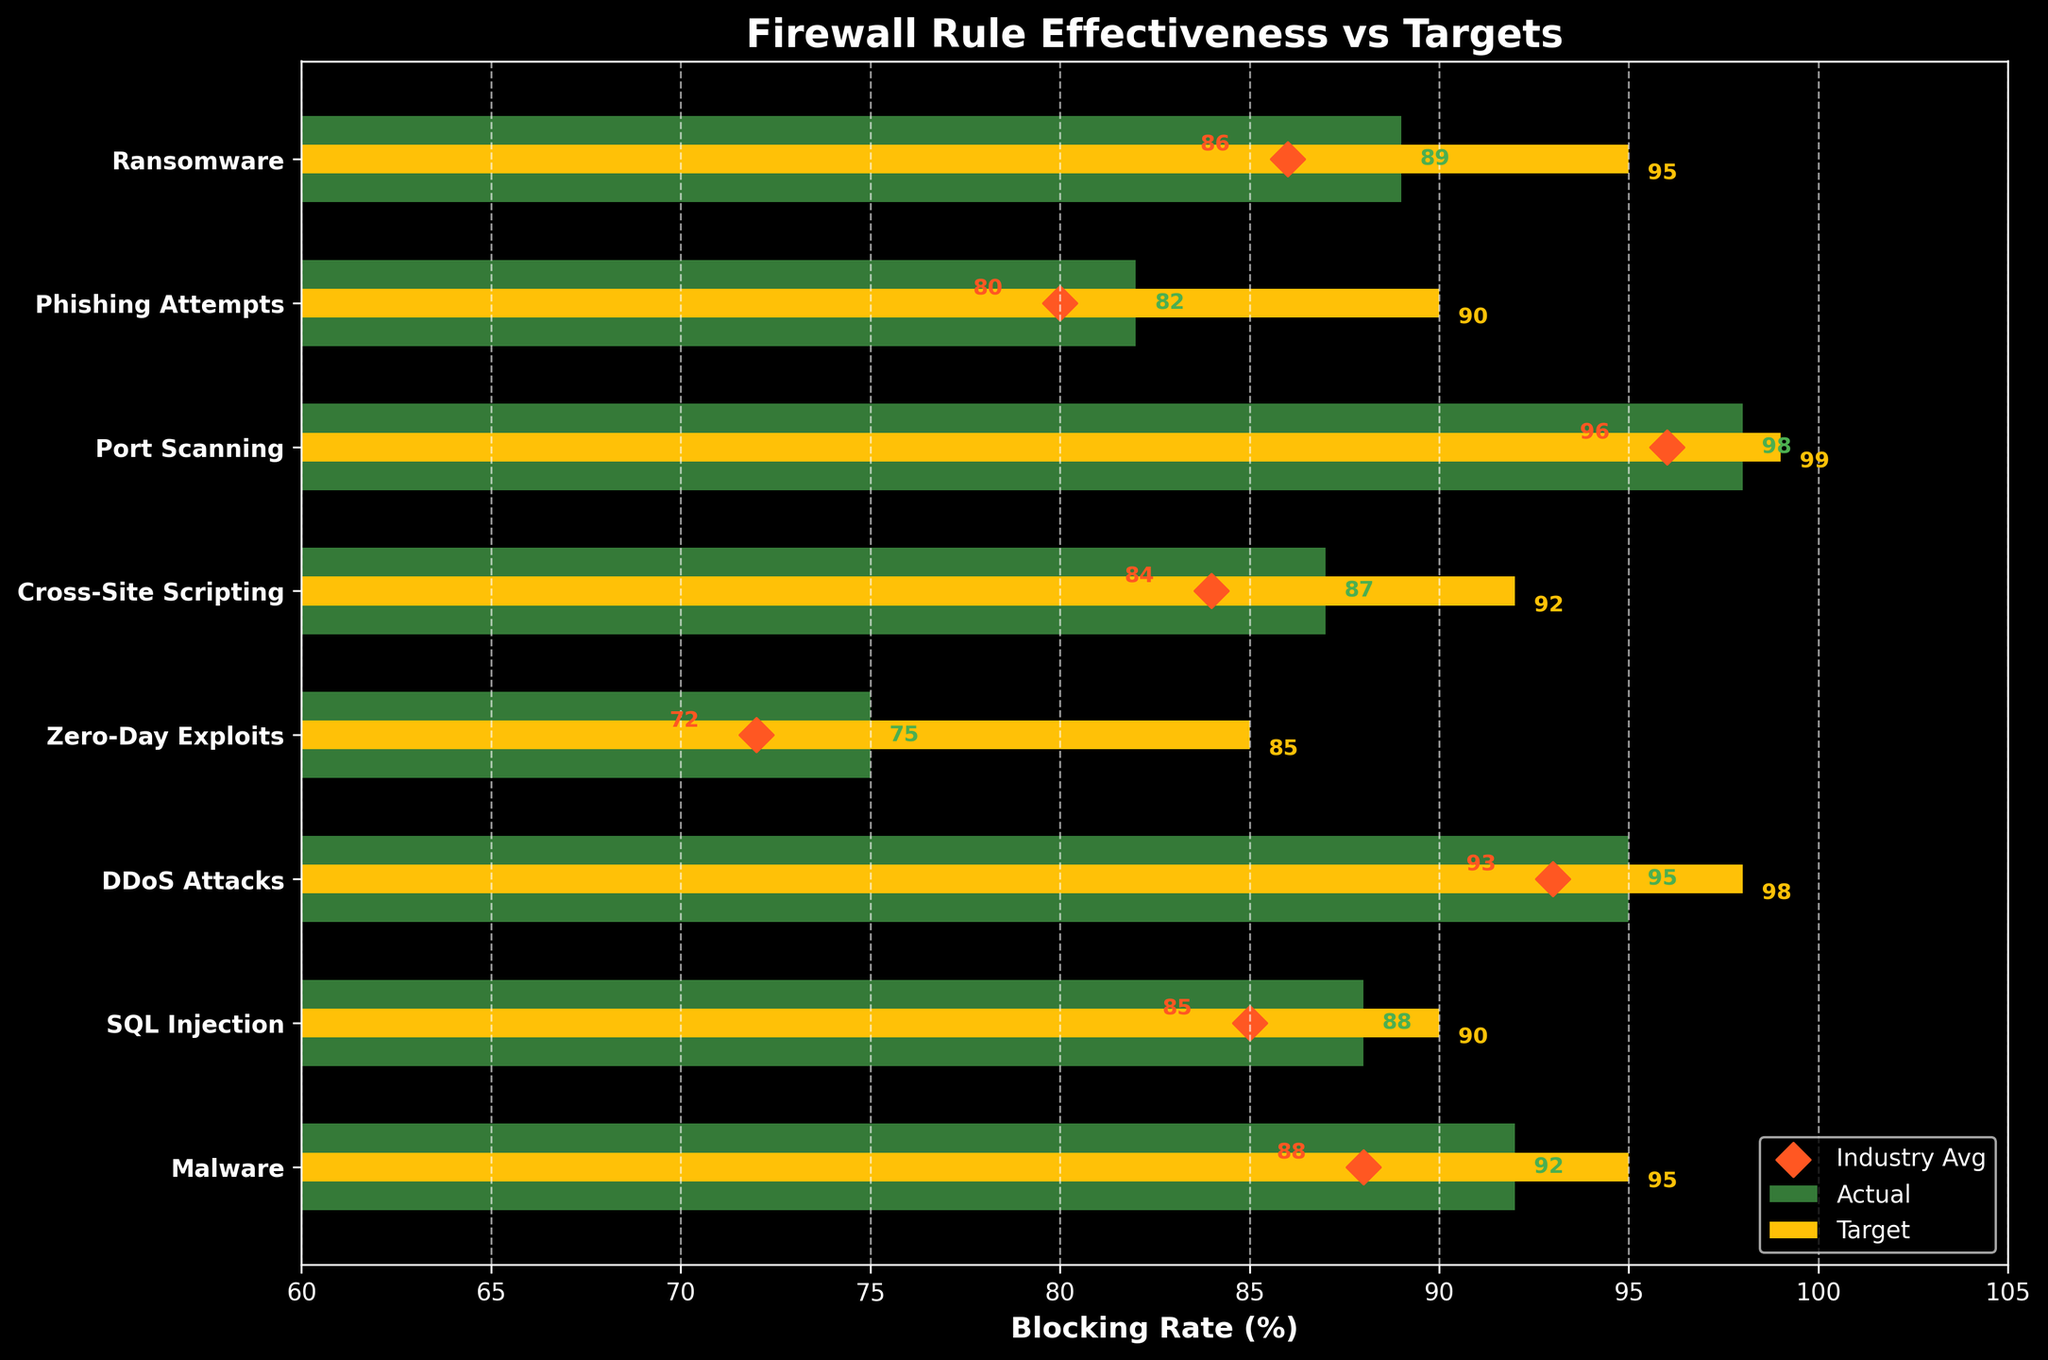What's the title of the figure? The title is typically at the top of the chart. Reading it directly from the figure should give us the necessary information.
Answer: Firewall Rule Effectiveness vs Targets Which Threat Category has the highest Actual Blocking Rate? To answer this, we look at the lengths of the green bars and identify the longest one.
Answer: Port Scanning Are there any Threat Categories where the Actual Blocking Rate is below the Industry Average? Compare the green bars (Actual Blocking Rate) to the red diamonds (Industry Average) for each threat.
Answer: No What's the difference between the Target Threshold and the Actual Blocking Rate for Malware? Identify the values on the chart for both Target Threshold and Actual Blocking Rate for Malware and calculate the difference: 95 (Target) - 92 (Actual).
Answer: 3 Which Threat Category has the lowest Actual Blocking Rate? Compare the lengths of all the green bars to find the shortest one.
Answer: Zero-Day Exploits For SQL Injection, how does the Actual Blocking Rate compare to the Target Threshold and Industry Average? Locate the values for SQL Injection, then compare the green bar to the yellow bar and the red diamond.
Answer: Actual is 2 below Target and 3 above Industry Average Which Threat Categories exceed their Target Thresholds? Compare the lengths of green bars to yellow bars for each category. Identify which are longer.
Answer: None What is the overall trend in the Actual Blocking Rates as compared to the Industry Average across all Threat Categories? Look at the positions of green bars relative to red diamonds across all categories to see if there is a general pattern.
Answer: Generally higher than Industry Average 